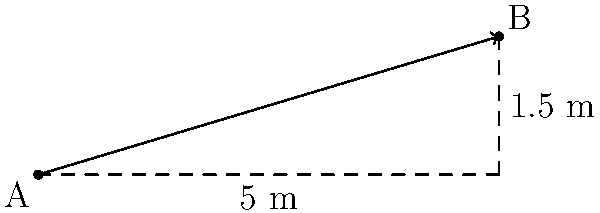As the club owner, you need to install a new accessibility ramp for your themed parties. The ramp will extend 5 meters horizontally and rise 1.5 meters vertically. What is the slope of this ramp, and does it meet the Americans with Disabilities Act (ADA) requirement that the maximum slope for a ramp should not exceed 1:12 (0.083 or 8.33%)? To solve this problem, we'll follow these steps:

1. Calculate the slope of the ramp:
   The slope is defined as the ratio of vertical rise to horizontal run.
   
   Slope = $\frac{\text{Rise}}{\text{Run}} = \frac{\text{Vertical distance}}{\text{Horizontal distance}}$

   In this case:
   Rise = 1.5 meters
   Run = 5 meters

   Slope = $\frac{1.5 \text{ m}}{5 \text{ m}} = 0.3$

2. Convert the slope to a percentage:
   Percentage = Slope × 100%
   Percentage = 0.3 × 100% = 30%

3. Compare to ADA requirements:
   ADA maximum slope: 1:12 = $\frac{1}{12} \approx 0.083$ or 8.33%
   Our ramp slope: 0.3 or 30%

4. Determine if the ramp meets ADA requirements:
   30% > 8.33%, so the ramp does not meet ADA requirements.

5. Express the slope as a ratio:
   The slope of 0.3 can be expressed as 3:10 (simplifying 30:100).

Therefore, the slope of the ramp is 0.3 (or 30% or 3:10), which exceeds the ADA maximum slope requirement of 1:12 (8.33%).
Answer: Slope: 0.3 (30% or 3:10); Does not meet ADA requirements 